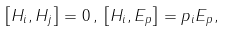Convert formula to latex. <formula><loc_0><loc_0><loc_500><loc_500>\left [ H _ { i } , H _ { j } \right ] = 0 \, , \, \left [ H _ { i } , E _ { p } \right ] = p _ { i } E _ { p } ,</formula> 